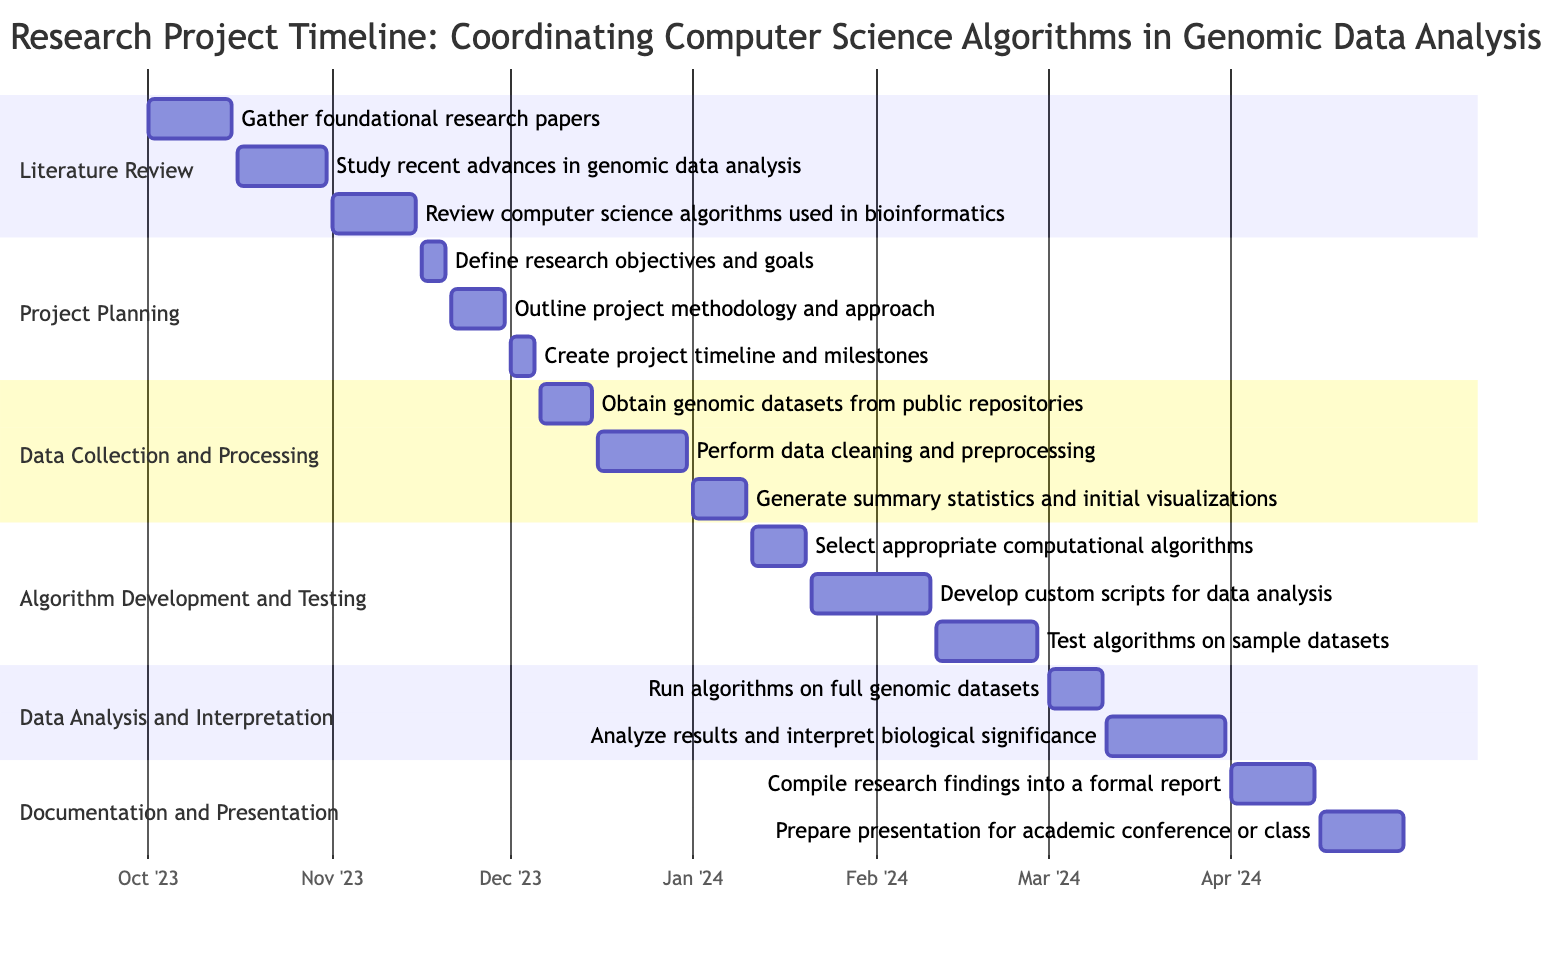What is the duration of the Literature Review phase? The Literature Review phase starts on October 1, 2023, and ends on November 15, 2023. To find the duration, I subtract the start date from the end date: November 15 minus October 1 gives a duration of 45 days.
Answer: 45 days How many tasks are involved in the Data Collection and Processing phase? The Data Collection and Processing phase contains three tasks: 1) Obtain genomic datasets, 2) Perform data cleaning and preprocessing, and 3) Generate summary statistics and initial visualizations. Therefore, the total number of tasks is three.
Answer: 3 tasks What task follows the Compile research findings into a formal report task? The task Compile research findings into a formal report ends on April 15, 2024, and the next task, Prepare presentation for academic conference or class, starts on April 16, 2024. Thus, the following task is Prepare presentation for academic conference or class.
Answer: Prepare presentation for academic conference or class What is the start date of the Algorithm Development and Testing phase? The Algorithm Development and Testing phase starts with the task Select appropriate computational algorithms, which begins on January 11, 2024. Identifying the start date of this task gives me the phase start date as January 11, 2024.
Answer: January 11, 2024 Which phase has the earliest starting task? The earliest starting task is Gather foundational research papers, which begins on October 1, 2023, during the Literature Review phase. Therefore, the phase with the earliest starting task is Literature Review.
Answer: Literature Review What is the total number of phases in the project timeline? The project consists of six phases: 1) Literature Review, 2) Project Planning, 3) Data Collection and Processing, 4) Algorithm Development and Testing, 5) Data Analysis and Interpretation, and 6) Documentation and Presentation. Thus, the total number of phases is six.
Answer: 6 phases What is the end date for the project? The final task in the Gantt chart, Prepare presentation for academic conference or class, ends on April 30, 2024. This indicates that the entire project concludes on this date.
Answer: April 30, 2024 